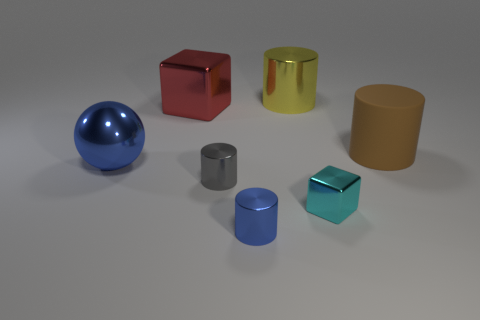Subtract all brown spheres. Subtract all gray cylinders. How many spheres are left? 1 Add 2 large spheres. How many objects exist? 9 Subtract all spheres. How many objects are left? 6 Subtract all large blue shiny things. Subtract all red cubes. How many objects are left? 5 Add 4 matte cylinders. How many matte cylinders are left? 5 Add 2 blocks. How many blocks exist? 4 Subtract 0 cyan cylinders. How many objects are left? 7 